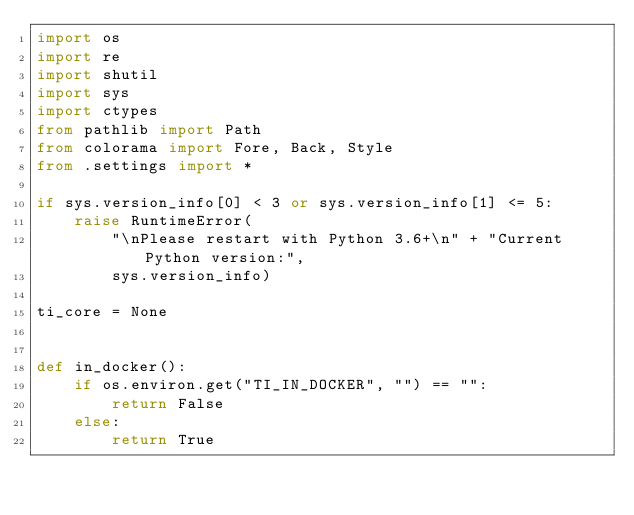Convert code to text. <code><loc_0><loc_0><loc_500><loc_500><_Python_>import os
import re
import shutil
import sys
import ctypes
from pathlib import Path
from colorama import Fore, Back, Style
from .settings import *

if sys.version_info[0] < 3 or sys.version_info[1] <= 5:
    raise RuntimeError(
        "\nPlease restart with Python 3.6+\n" + "Current Python version:",
        sys.version_info)

ti_core = None


def in_docker():
    if os.environ.get("TI_IN_DOCKER", "") == "":
        return False
    else:
        return True

</code> 